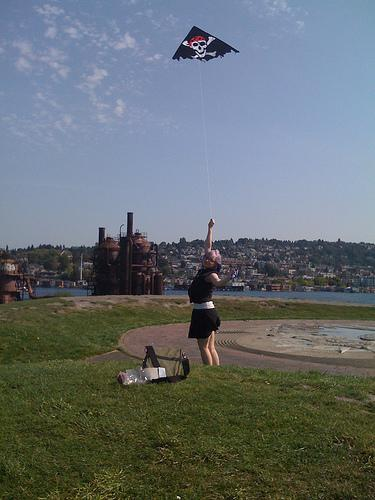Question: who is in the photo?
Choices:
A. A woman.
B. A child.
C. Newborn baby.
D. Dog.
Answer with the letter. Answer: A Question: why is it so bright?
Choices:
A. The lights are on.
B. Sunny.
C. The camera flashed.
D. There is a lightning strike.
Answer with the letter. Answer: B Question: what is the weather?
Choices:
A. Stormy.
B. Snowing.
C. Raining.
D. Clear skies.
Answer with the letter. Answer: D Question: what is the woman doing?
Choices:
A. Sitting.
B. Smiling.
C. Standing.
D. Talking.
Answer with the letter. Answer: C 